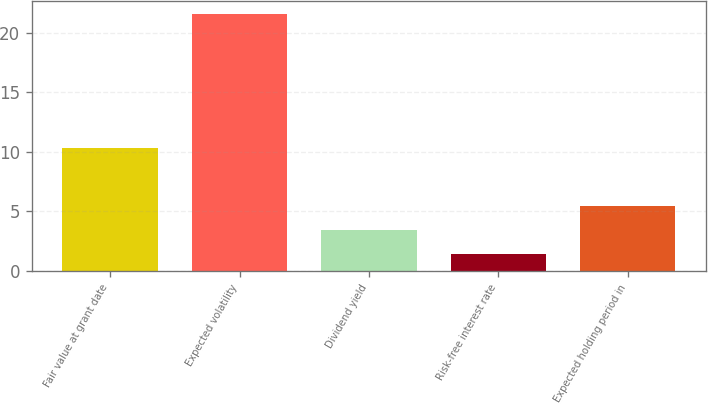Convert chart to OTSL. <chart><loc_0><loc_0><loc_500><loc_500><bar_chart><fcel>Fair value at grant date<fcel>Expected volatility<fcel>Dividend yield<fcel>Risk-free interest rate<fcel>Expected holding period in<nl><fcel>10.35<fcel>21.6<fcel>3.42<fcel>1.4<fcel>5.44<nl></chart> 